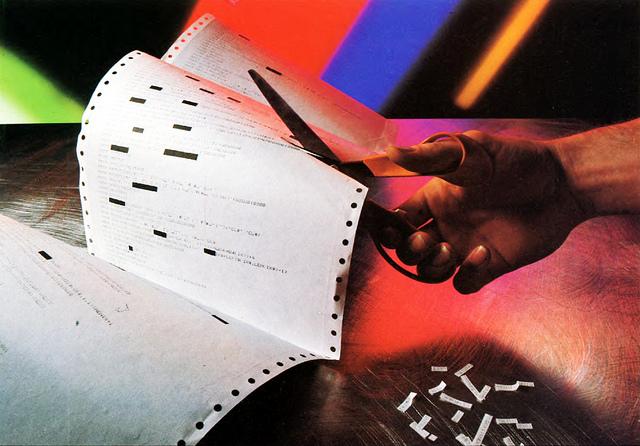What kind of material is being cut?
Short answer required. Paper. What is being held?
Short answer required. Scissors. Is this old printer paper or new?
Keep it brief. Old. 